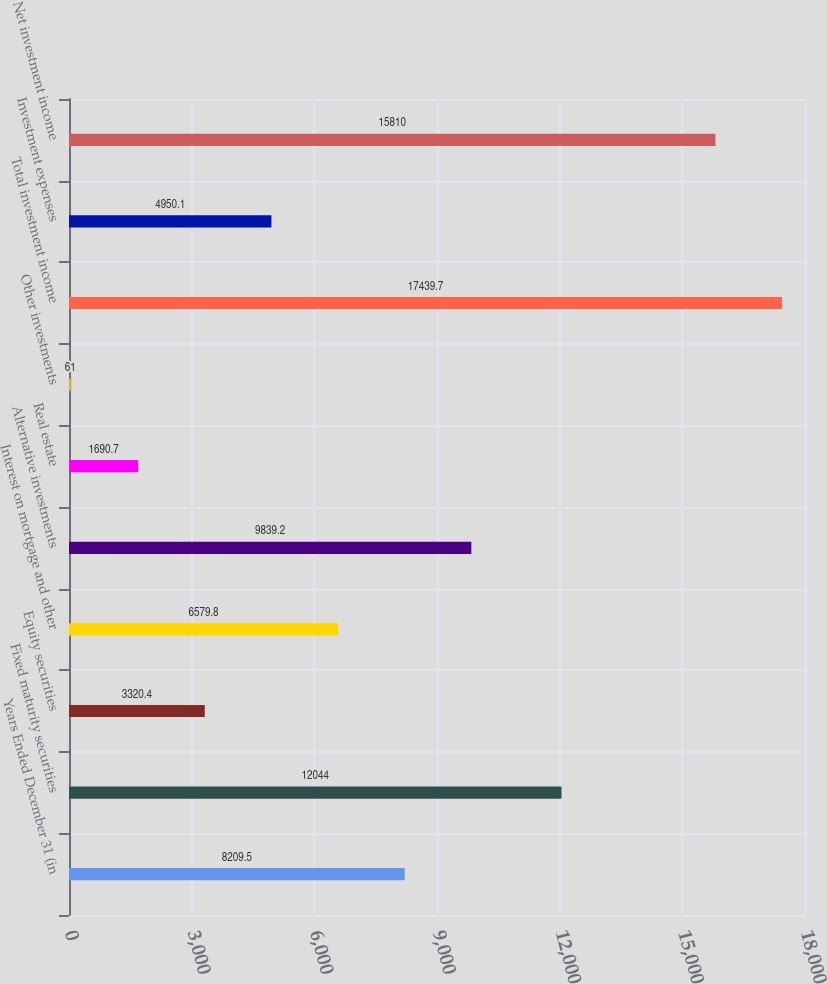Convert chart. <chart><loc_0><loc_0><loc_500><loc_500><bar_chart><fcel>Years Ended December 31 (in<fcel>Fixed maturity securities<fcel>Equity securities<fcel>Interest on mortgage and other<fcel>Alternative investments<fcel>Real estate<fcel>Other investments<fcel>Total investment income<fcel>Investment expenses<fcel>Net investment income<nl><fcel>8209.5<fcel>12044<fcel>3320.4<fcel>6579.8<fcel>9839.2<fcel>1690.7<fcel>61<fcel>17439.7<fcel>4950.1<fcel>15810<nl></chart> 